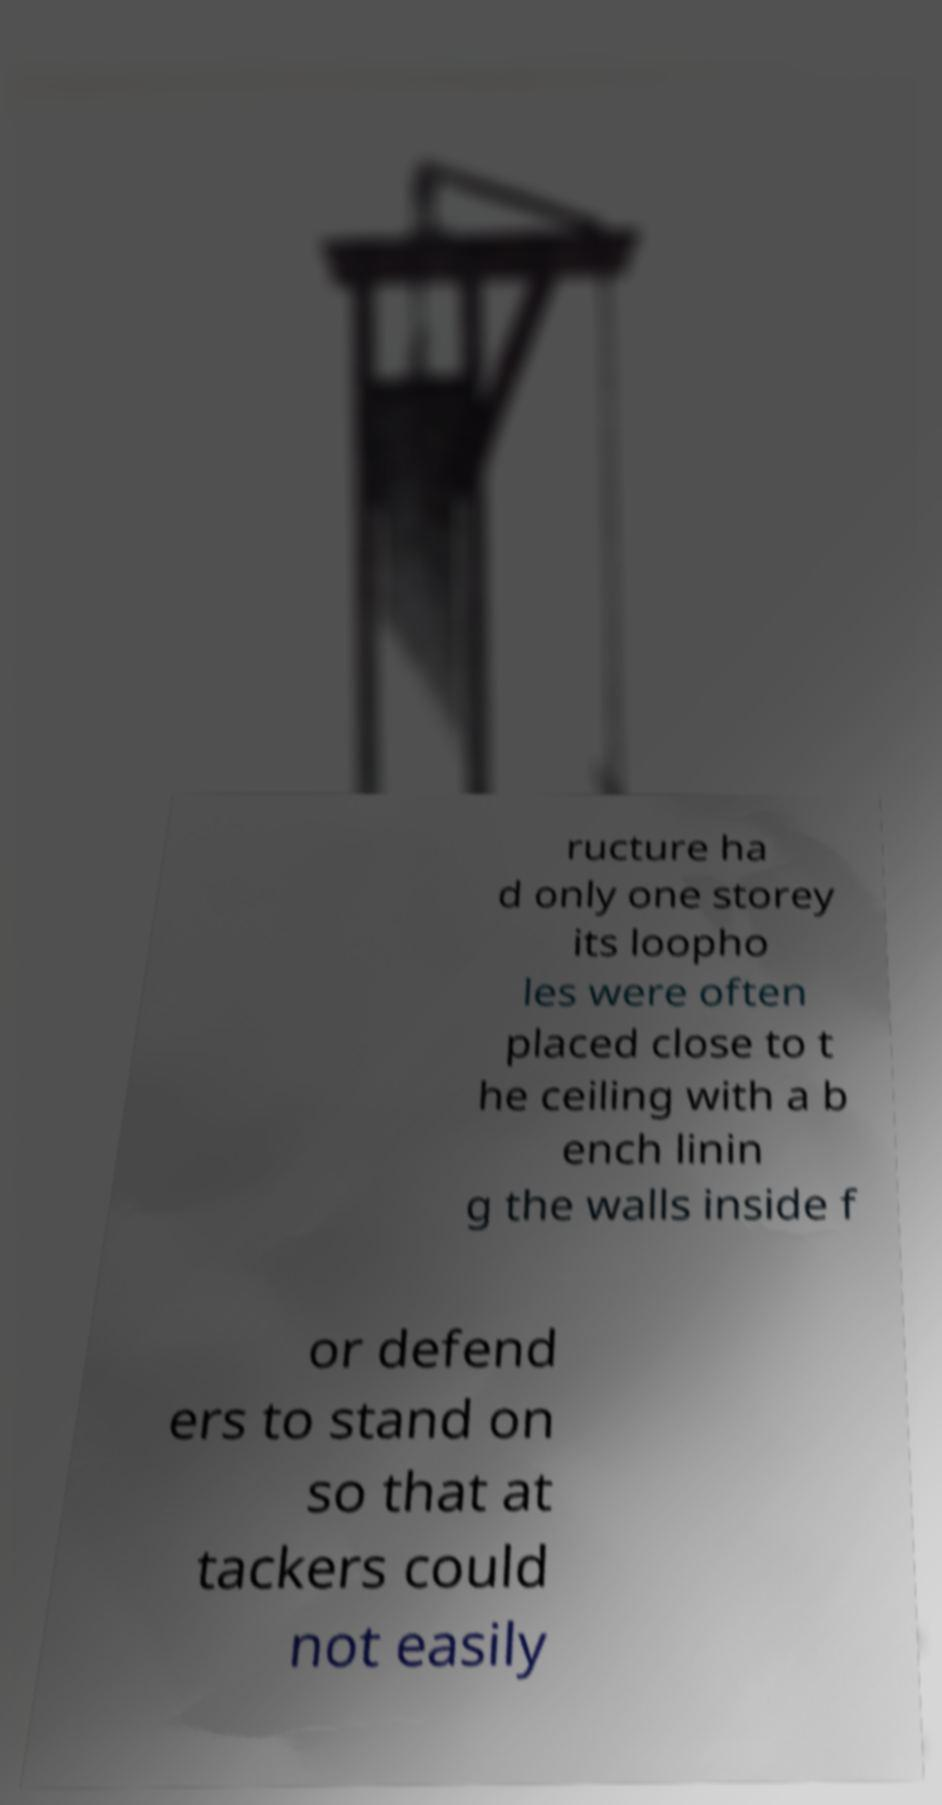Please read and relay the text visible in this image. What does it say? ructure ha d only one storey its loopho les were often placed close to t he ceiling with a b ench linin g the walls inside f or defend ers to stand on so that at tackers could not easily 